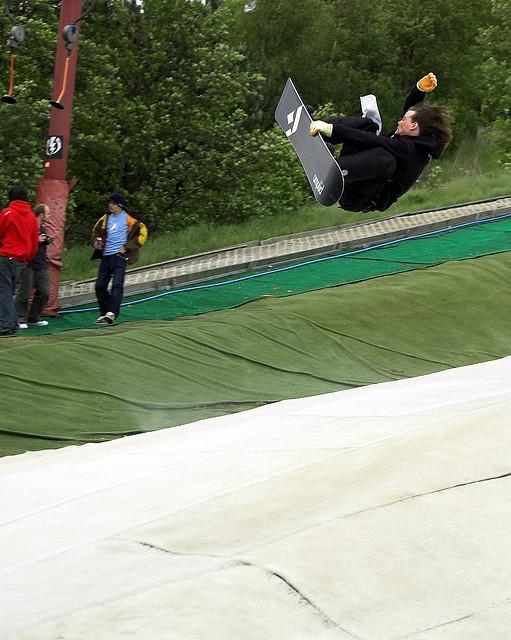What type of board is this?

Choices:
A) topple board
B) skate board
C) snow board
D) balance board skate board 